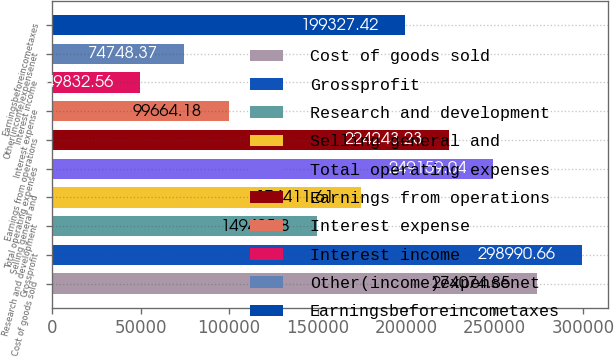Convert chart to OTSL. <chart><loc_0><loc_0><loc_500><loc_500><bar_chart><fcel>Cost of goods sold<fcel>Grossprofit<fcel>Research and development<fcel>Selling general and<fcel>Total operating expenses<fcel>Earnings from operations<fcel>Interest expense<fcel>Interest income<fcel>Other(income)expensenet<fcel>Earningsbeforeincometaxes<nl><fcel>274075<fcel>298991<fcel>149496<fcel>174412<fcel>249159<fcel>224243<fcel>99664.2<fcel>49832.6<fcel>74748.4<fcel>199327<nl></chart> 